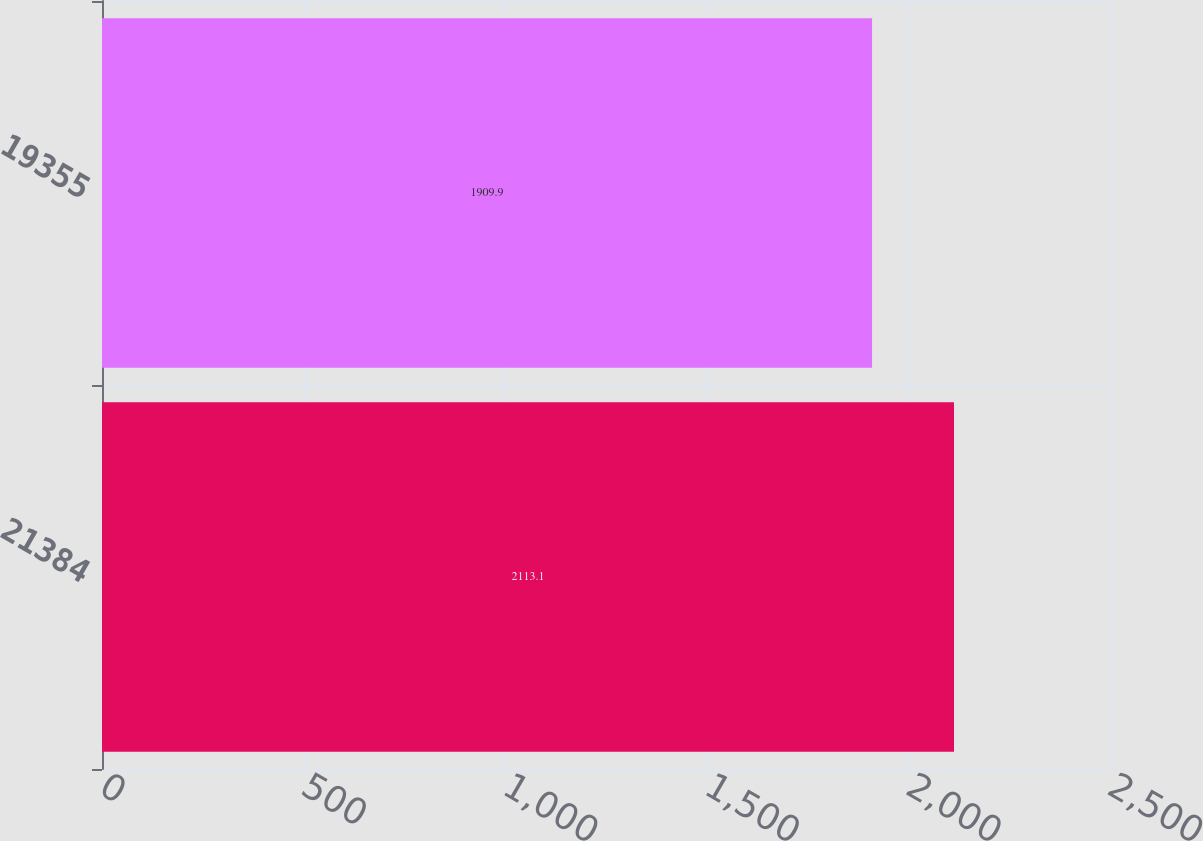Convert chart. <chart><loc_0><loc_0><loc_500><loc_500><bar_chart><fcel>21384<fcel>19355<nl><fcel>2113.1<fcel>1909.9<nl></chart> 